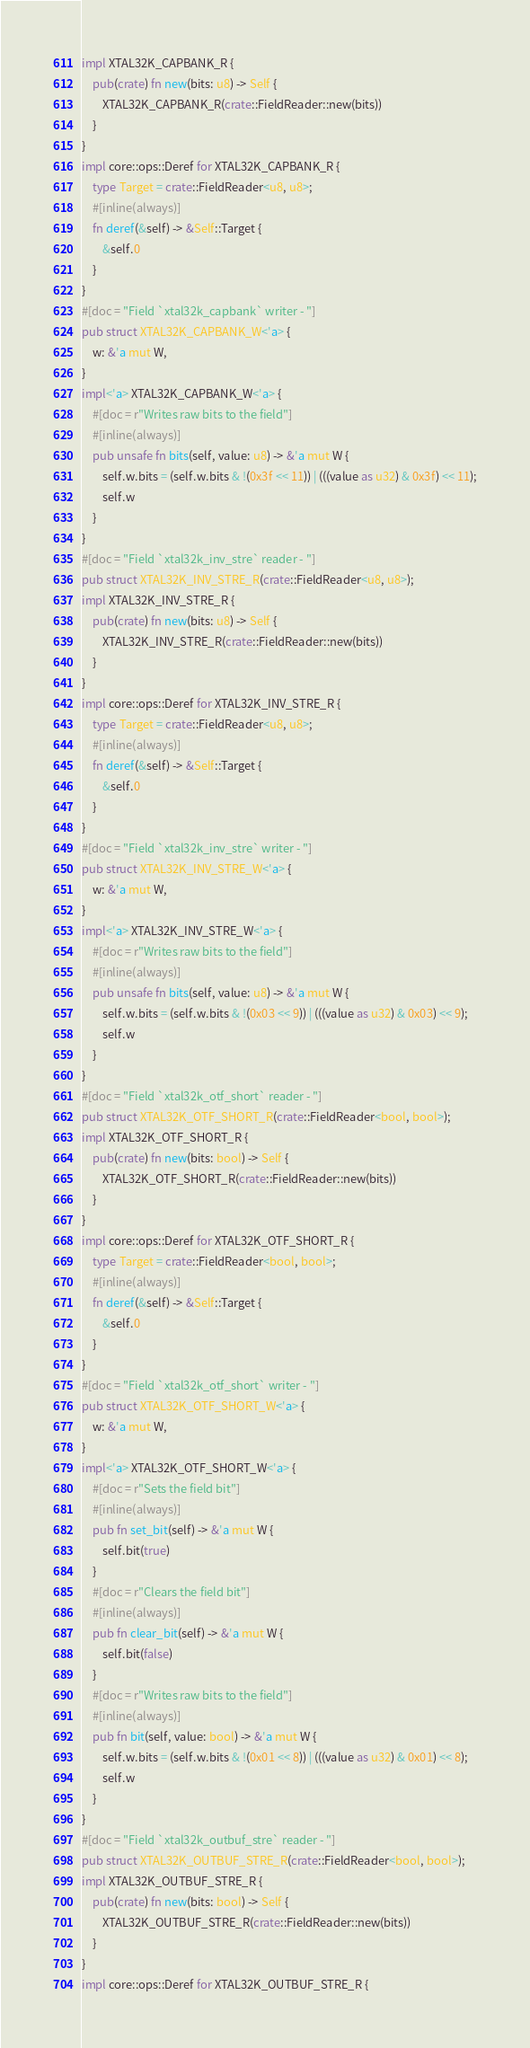<code> <loc_0><loc_0><loc_500><loc_500><_Rust_>impl XTAL32K_CAPBANK_R {
    pub(crate) fn new(bits: u8) -> Self {
        XTAL32K_CAPBANK_R(crate::FieldReader::new(bits))
    }
}
impl core::ops::Deref for XTAL32K_CAPBANK_R {
    type Target = crate::FieldReader<u8, u8>;
    #[inline(always)]
    fn deref(&self) -> &Self::Target {
        &self.0
    }
}
#[doc = "Field `xtal32k_capbank` writer - "]
pub struct XTAL32K_CAPBANK_W<'a> {
    w: &'a mut W,
}
impl<'a> XTAL32K_CAPBANK_W<'a> {
    #[doc = r"Writes raw bits to the field"]
    #[inline(always)]
    pub unsafe fn bits(self, value: u8) -> &'a mut W {
        self.w.bits = (self.w.bits & !(0x3f << 11)) | (((value as u32) & 0x3f) << 11);
        self.w
    }
}
#[doc = "Field `xtal32k_inv_stre` reader - "]
pub struct XTAL32K_INV_STRE_R(crate::FieldReader<u8, u8>);
impl XTAL32K_INV_STRE_R {
    pub(crate) fn new(bits: u8) -> Self {
        XTAL32K_INV_STRE_R(crate::FieldReader::new(bits))
    }
}
impl core::ops::Deref for XTAL32K_INV_STRE_R {
    type Target = crate::FieldReader<u8, u8>;
    #[inline(always)]
    fn deref(&self) -> &Self::Target {
        &self.0
    }
}
#[doc = "Field `xtal32k_inv_stre` writer - "]
pub struct XTAL32K_INV_STRE_W<'a> {
    w: &'a mut W,
}
impl<'a> XTAL32K_INV_STRE_W<'a> {
    #[doc = r"Writes raw bits to the field"]
    #[inline(always)]
    pub unsafe fn bits(self, value: u8) -> &'a mut W {
        self.w.bits = (self.w.bits & !(0x03 << 9)) | (((value as u32) & 0x03) << 9);
        self.w
    }
}
#[doc = "Field `xtal32k_otf_short` reader - "]
pub struct XTAL32K_OTF_SHORT_R(crate::FieldReader<bool, bool>);
impl XTAL32K_OTF_SHORT_R {
    pub(crate) fn new(bits: bool) -> Self {
        XTAL32K_OTF_SHORT_R(crate::FieldReader::new(bits))
    }
}
impl core::ops::Deref for XTAL32K_OTF_SHORT_R {
    type Target = crate::FieldReader<bool, bool>;
    #[inline(always)]
    fn deref(&self) -> &Self::Target {
        &self.0
    }
}
#[doc = "Field `xtal32k_otf_short` writer - "]
pub struct XTAL32K_OTF_SHORT_W<'a> {
    w: &'a mut W,
}
impl<'a> XTAL32K_OTF_SHORT_W<'a> {
    #[doc = r"Sets the field bit"]
    #[inline(always)]
    pub fn set_bit(self) -> &'a mut W {
        self.bit(true)
    }
    #[doc = r"Clears the field bit"]
    #[inline(always)]
    pub fn clear_bit(self) -> &'a mut W {
        self.bit(false)
    }
    #[doc = r"Writes raw bits to the field"]
    #[inline(always)]
    pub fn bit(self, value: bool) -> &'a mut W {
        self.w.bits = (self.w.bits & !(0x01 << 8)) | (((value as u32) & 0x01) << 8);
        self.w
    }
}
#[doc = "Field `xtal32k_outbuf_stre` reader - "]
pub struct XTAL32K_OUTBUF_STRE_R(crate::FieldReader<bool, bool>);
impl XTAL32K_OUTBUF_STRE_R {
    pub(crate) fn new(bits: bool) -> Self {
        XTAL32K_OUTBUF_STRE_R(crate::FieldReader::new(bits))
    }
}
impl core::ops::Deref for XTAL32K_OUTBUF_STRE_R {</code> 